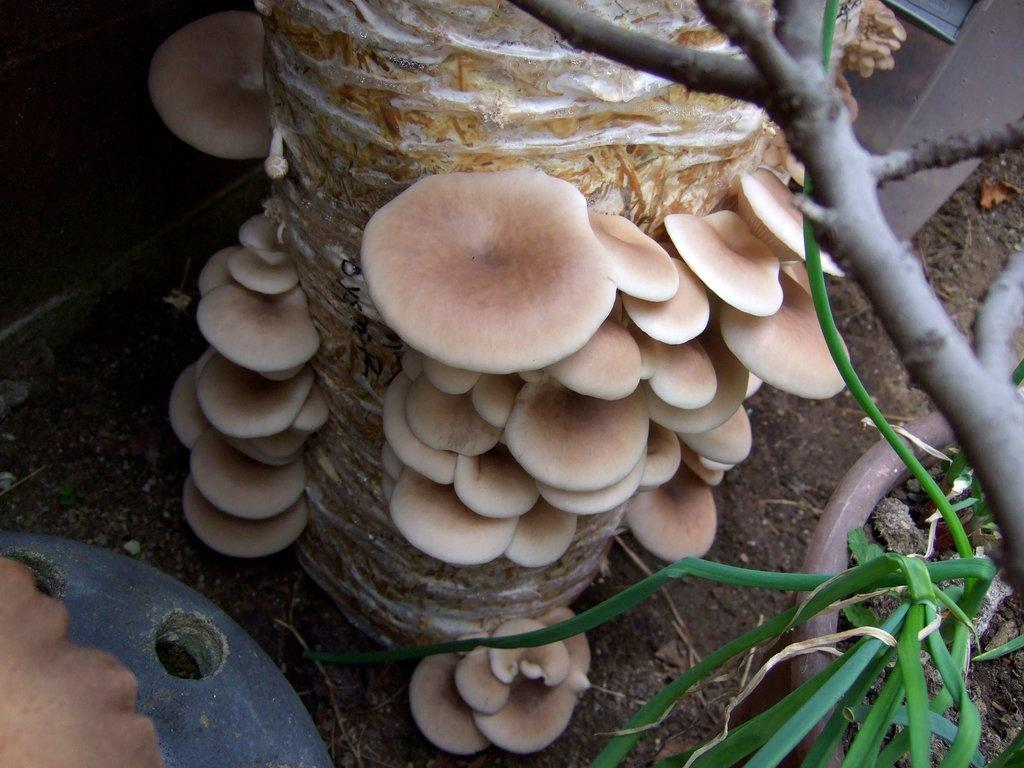What type of organism is present in the image? There is a fungus in the image. Can you describe the color of the fungus? The fungus is cream-colored. What other living organisms can be seen in the image? There are plants in the image. What is the color of the plants? The plants are green. How many pizzas are visible in the image? There are no pizzas present in the image. What type of body is shown interacting with the fungus in the image? There is no body present in the image; it only features the fungus and plants. 